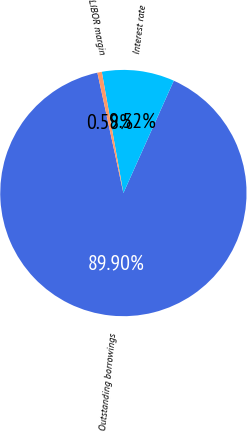Convert chart. <chart><loc_0><loc_0><loc_500><loc_500><pie_chart><fcel>Outstanding borrowings<fcel>Interest rate<fcel>LIBOR margin<nl><fcel>89.9%<fcel>9.52%<fcel>0.58%<nl></chart> 